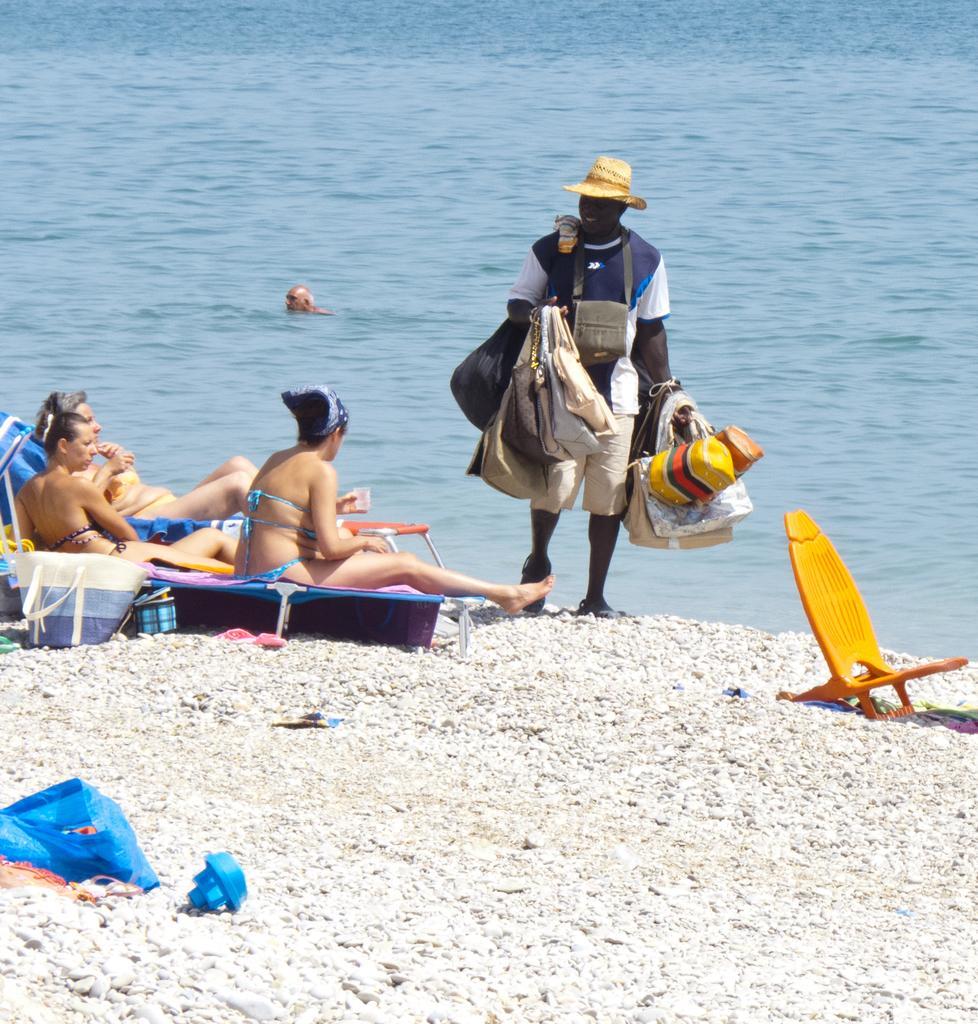Please provide a concise description of this image. In this picture we can see few people, on the left side of the image we can see three women, they are sitting on the chairs, in front of them we can see a man, he is carrying bags, in the background we can find a man in the water, on the left side of the image we can see few bags. 